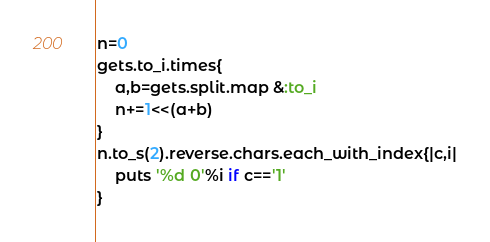Convert code to text. <code><loc_0><loc_0><loc_500><loc_500><_Ruby_>n=0
gets.to_i.times{
	a,b=gets.split.map &:to_i
	n+=1<<(a+b)
}
n.to_s(2).reverse.chars.each_with_index{|c,i|
	puts '%d 0'%i if c=='1'
}</code> 